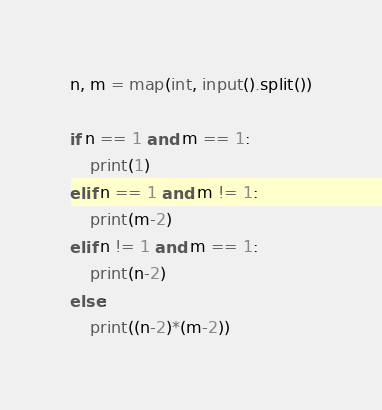Convert code to text. <code><loc_0><loc_0><loc_500><loc_500><_Python_>n, m = map(int, input().split())

if n == 1 and m == 1:
    print(1)
elif n == 1 and m != 1:
    print(m-2)
elif n != 1 and m == 1:
    print(n-2)
else:
    print((n-2)*(m-2))
</code> 